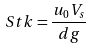Convert formula to latex. <formula><loc_0><loc_0><loc_500><loc_500>S t k = \frac { u _ { 0 } V _ { s } } { d g }</formula> 